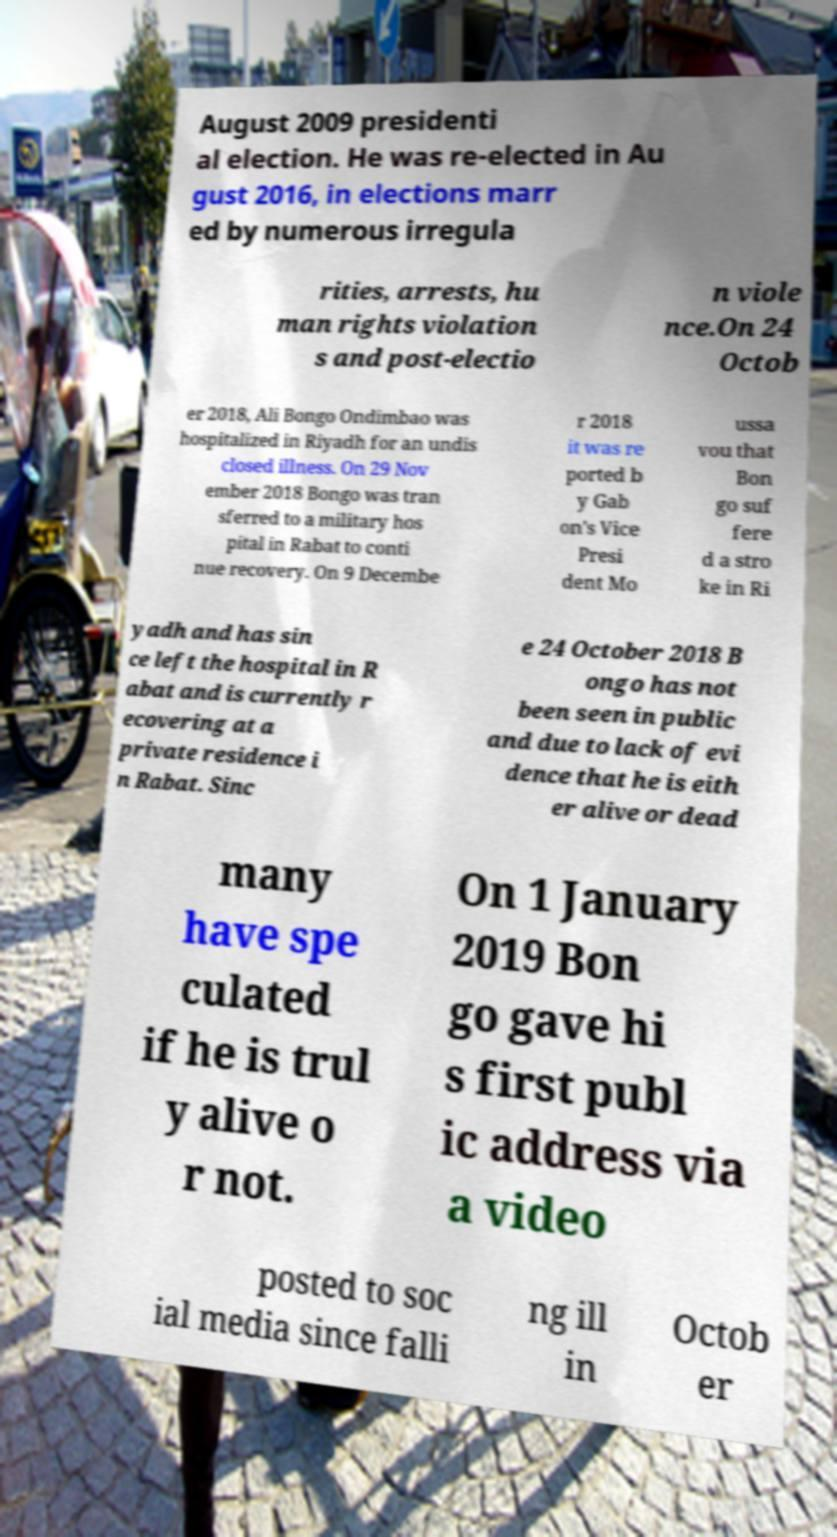Please read and relay the text visible in this image. What does it say? August 2009 presidenti al election. He was re-elected in Au gust 2016, in elections marr ed by numerous irregula rities, arrests, hu man rights violation s and post-electio n viole nce.On 24 Octob er 2018, Ali Bongo Ondimbao was hospitalized in Riyadh for an undis closed illness. On 29 Nov ember 2018 Bongo was tran sferred to a military hos pital in Rabat to conti nue recovery. On 9 Decembe r 2018 it was re ported b y Gab on's Vice Presi dent Mo ussa vou that Bon go suf fere d a stro ke in Ri yadh and has sin ce left the hospital in R abat and is currently r ecovering at a private residence i n Rabat. Sinc e 24 October 2018 B ongo has not been seen in public and due to lack of evi dence that he is eith er alive or dead many have spe culated if he is trul y alive o r not. On 1 January 2019 Bon go gave hi s first publ ic address via a video posted to soc ial media since falli ng ill in Octob er 